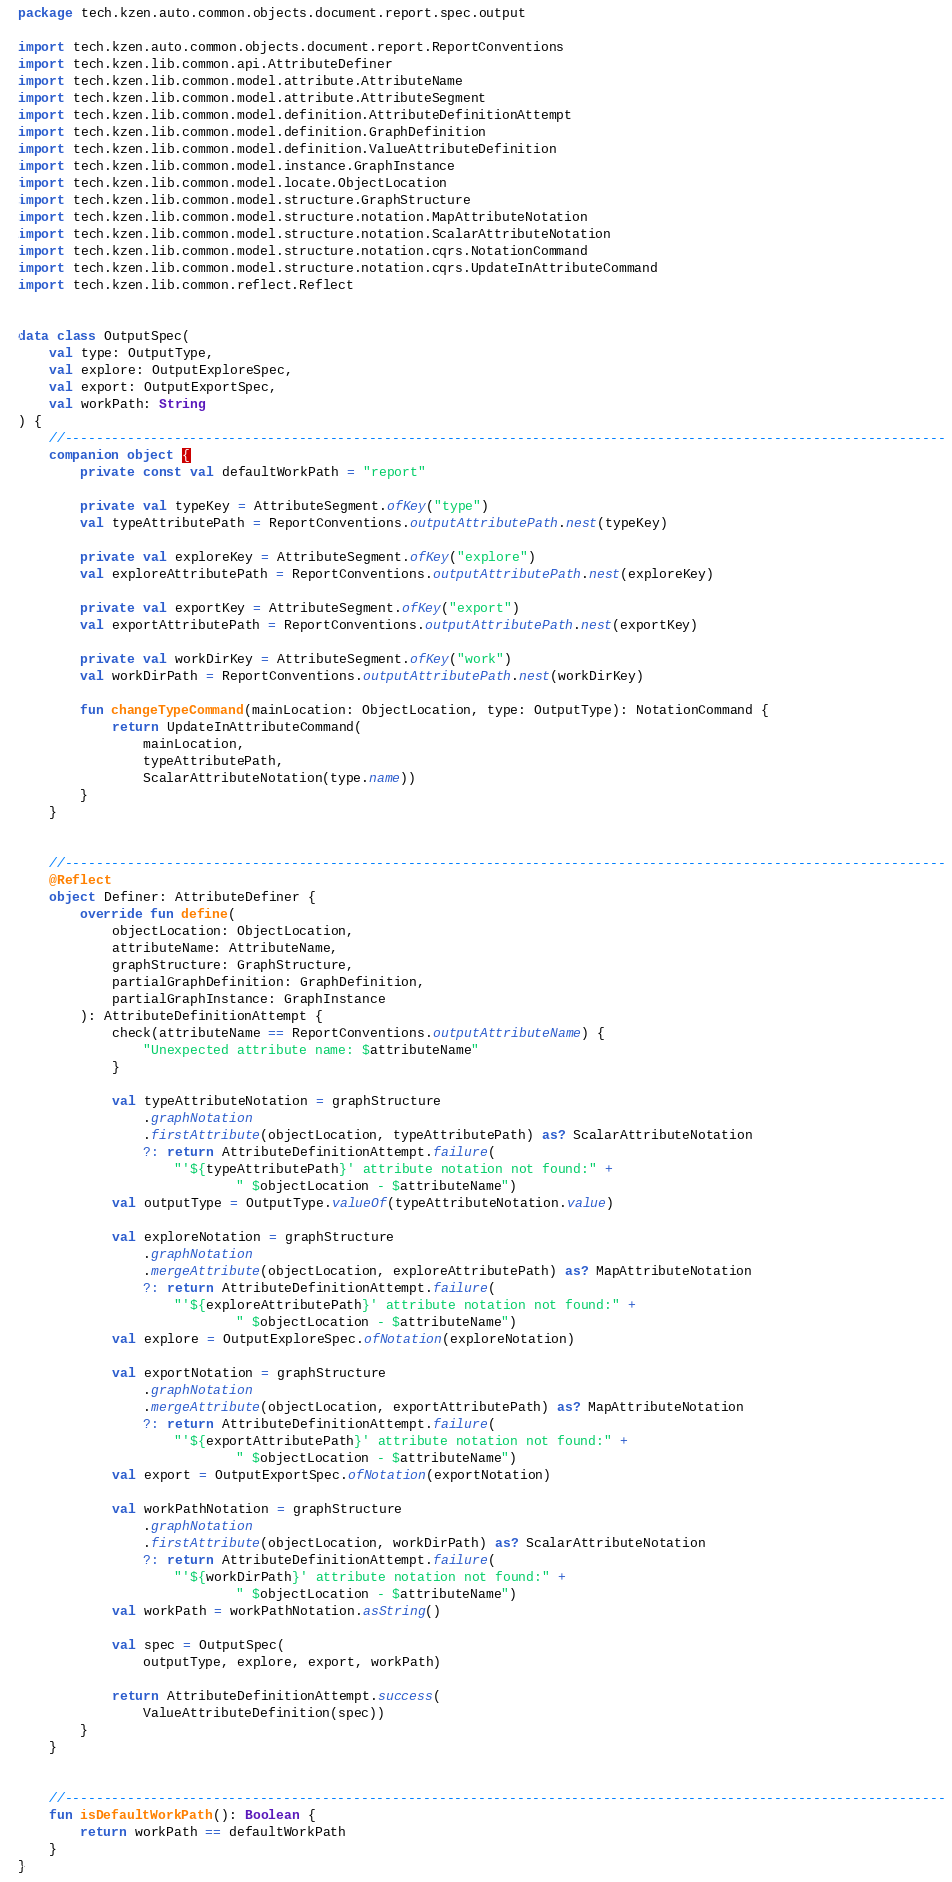<code> <loc_0><loc_0><loc_500><loc_500><_Kotlin_>package tech.kzen.auto.common.objects.document.report.spec.output

import tech.kzen.auto.common.objects.document.report.ReportConventions
import tech.kzen.lib.common.api.AttributeDefiner
import tech.kzen.lib.common.model.attribute.AttributeName
import tech.kzen.lib.common.model.attribute.AttributeSegment
import tech.kzen.lib.common.model.definition.AttributeDefinitionAttempt
import tech.kzen.lib.common.model.definition.GraphDefinition
import tech.kzen.lib.common.model.definition.ValueAttributeDefinition
import tech.kzen.lib.common.model.instance.GraphInstance
import tech.kzen.lib.common.model.locate.ObjectLocation
import tech.kzen.lib.common.model.structure.GraphStructure
import tech.kzen.lib.common.model.structure.notation.MapAttributeNotation
import tech.kzen.lib.common.model.structure.notation.ScalarAttributeNotation
import tech.kzen.lib.common.model.structure.notation.cqrs.NotationCommand
import tech.kzen.lib.common.model.structure.notation.cqrs.UpdateInAttributeCommand
import tech.kzen.lib.common.reflect.Reflect


data class OutputSpec(
    val type: OutputType,
    val explore: OutputExploreSpec,
    val export: OutputExportSpec,
    val workPath: String
) {
    //-----------------------------------------------------------------------------------------------------------------
    companion object {
        private const val defaultWorkPath = "report"

        private val typeKey = AttributeSegment.ofKey("type")
        val typeAttributePath = ReportConventions.outputAttributePath.nest(typeKey)

        private val exploreKey = AttributeSegment.ofKey("explore")
        val exploreAttributePath = ReportConventions.outputAttributePath.nest(exploreKey)

        private val exportKey = AttributeSegment.ofKey("export")
        val exportAttributePath = ReportConventions.outputAttributePath.nest(exportKey)

        private val workDirKey = AttributeSegment.ofKey("work")
        val workDirPath = ReportConventions.outputAttributePath.nest(workDirKey)

        fun changeTypeCommand(mainLocation: ObjectLocation, type: OutputType): NotationCommand {
            return UpdateInAttributeCommand(
                mainLocation,
                typeAttributePath,
                ScalarAttributeNotation(type.name))
        }
    }


    //-----------------------------------------------------------------------------------------------------------------
    @Reflect
    object Definer: AttributeDefiner {
        override fun define(
            objectLocation: ObjectLocation,
            attributeName: AttributeName,
            graphStructure: GraphStructure,
            partialGraphDefinition: GraphDefinition,
            partialGraphInstance: GraphInstance
        ): AttributeDefinitionAttempt {
            check(attributeName == ReportConventions.outputAttributeName) {
                "Unexpected attribute name: $attributeName"
            }

            val typeAttributeNotation = graphStructure
                .graphNotation
                .firstAttribute(objectLocation, typeAttributePath) as? ScalarAttributeNotation
                ?: return AttributeDefinitionAttempt.failure(
                    "'${typeAttributePath}' attribute notation not found:" +
                            " $objectLocation - $attributeName")
            val outputType = OutputType.valueOf(typeAttributeNotation.value)

            val exploreNotation = graphStructure
                .graphNotation
                .mergeAttribute(objectLocation, exploreAttributePath) as? MapAttributeNotation
                ?: return AttributeDefinitionAttempt.failure(
                    "'${exploreAttributePath}' attribute notation not found:" +
                            " $objectLocation - $attributeName")
            val explore = OutputExploreSpec.ofNotation(exploreNotation)

            val exportNotation = graphStructure
                .graphNotation
                .mergeAttribute(objectLocation, exportAttributePath) as? MapAttributeNotation
                ?: return AttributeDefinitionAttempt.failure(
                    "'${exportAttributePath}' attribute notation not found:" +
                            " $objectLocation - $attributeName")
            val export = OutputExportSpec.ofNotation(exportNotation)

            val workPathNotation = graphStructure
                .graphNotation
                .firstAttribute(objectLocation, workDirPath) as? ScalarAttributeNotation
                ?: return AttributeDefinitionAttempt.failure(
                    "'${workDirPath}' attribute notation not found:" +
                            " $objectLocation - $attributeName")
            val workPath = workPathNotation.asString()

            val spec = OutputSpec(
                outputType, explore, export, workPath)

            return AttributeDefinitionAttempt.success(
                ValueAttributeDefinition(spec))
        }
    }


    //-----------------------------------------------------------------------------------------------------------------
    fun isDefaultWorkPath(): Boolean {
        return workPath == defaultWorkPath
    }
}</code> 